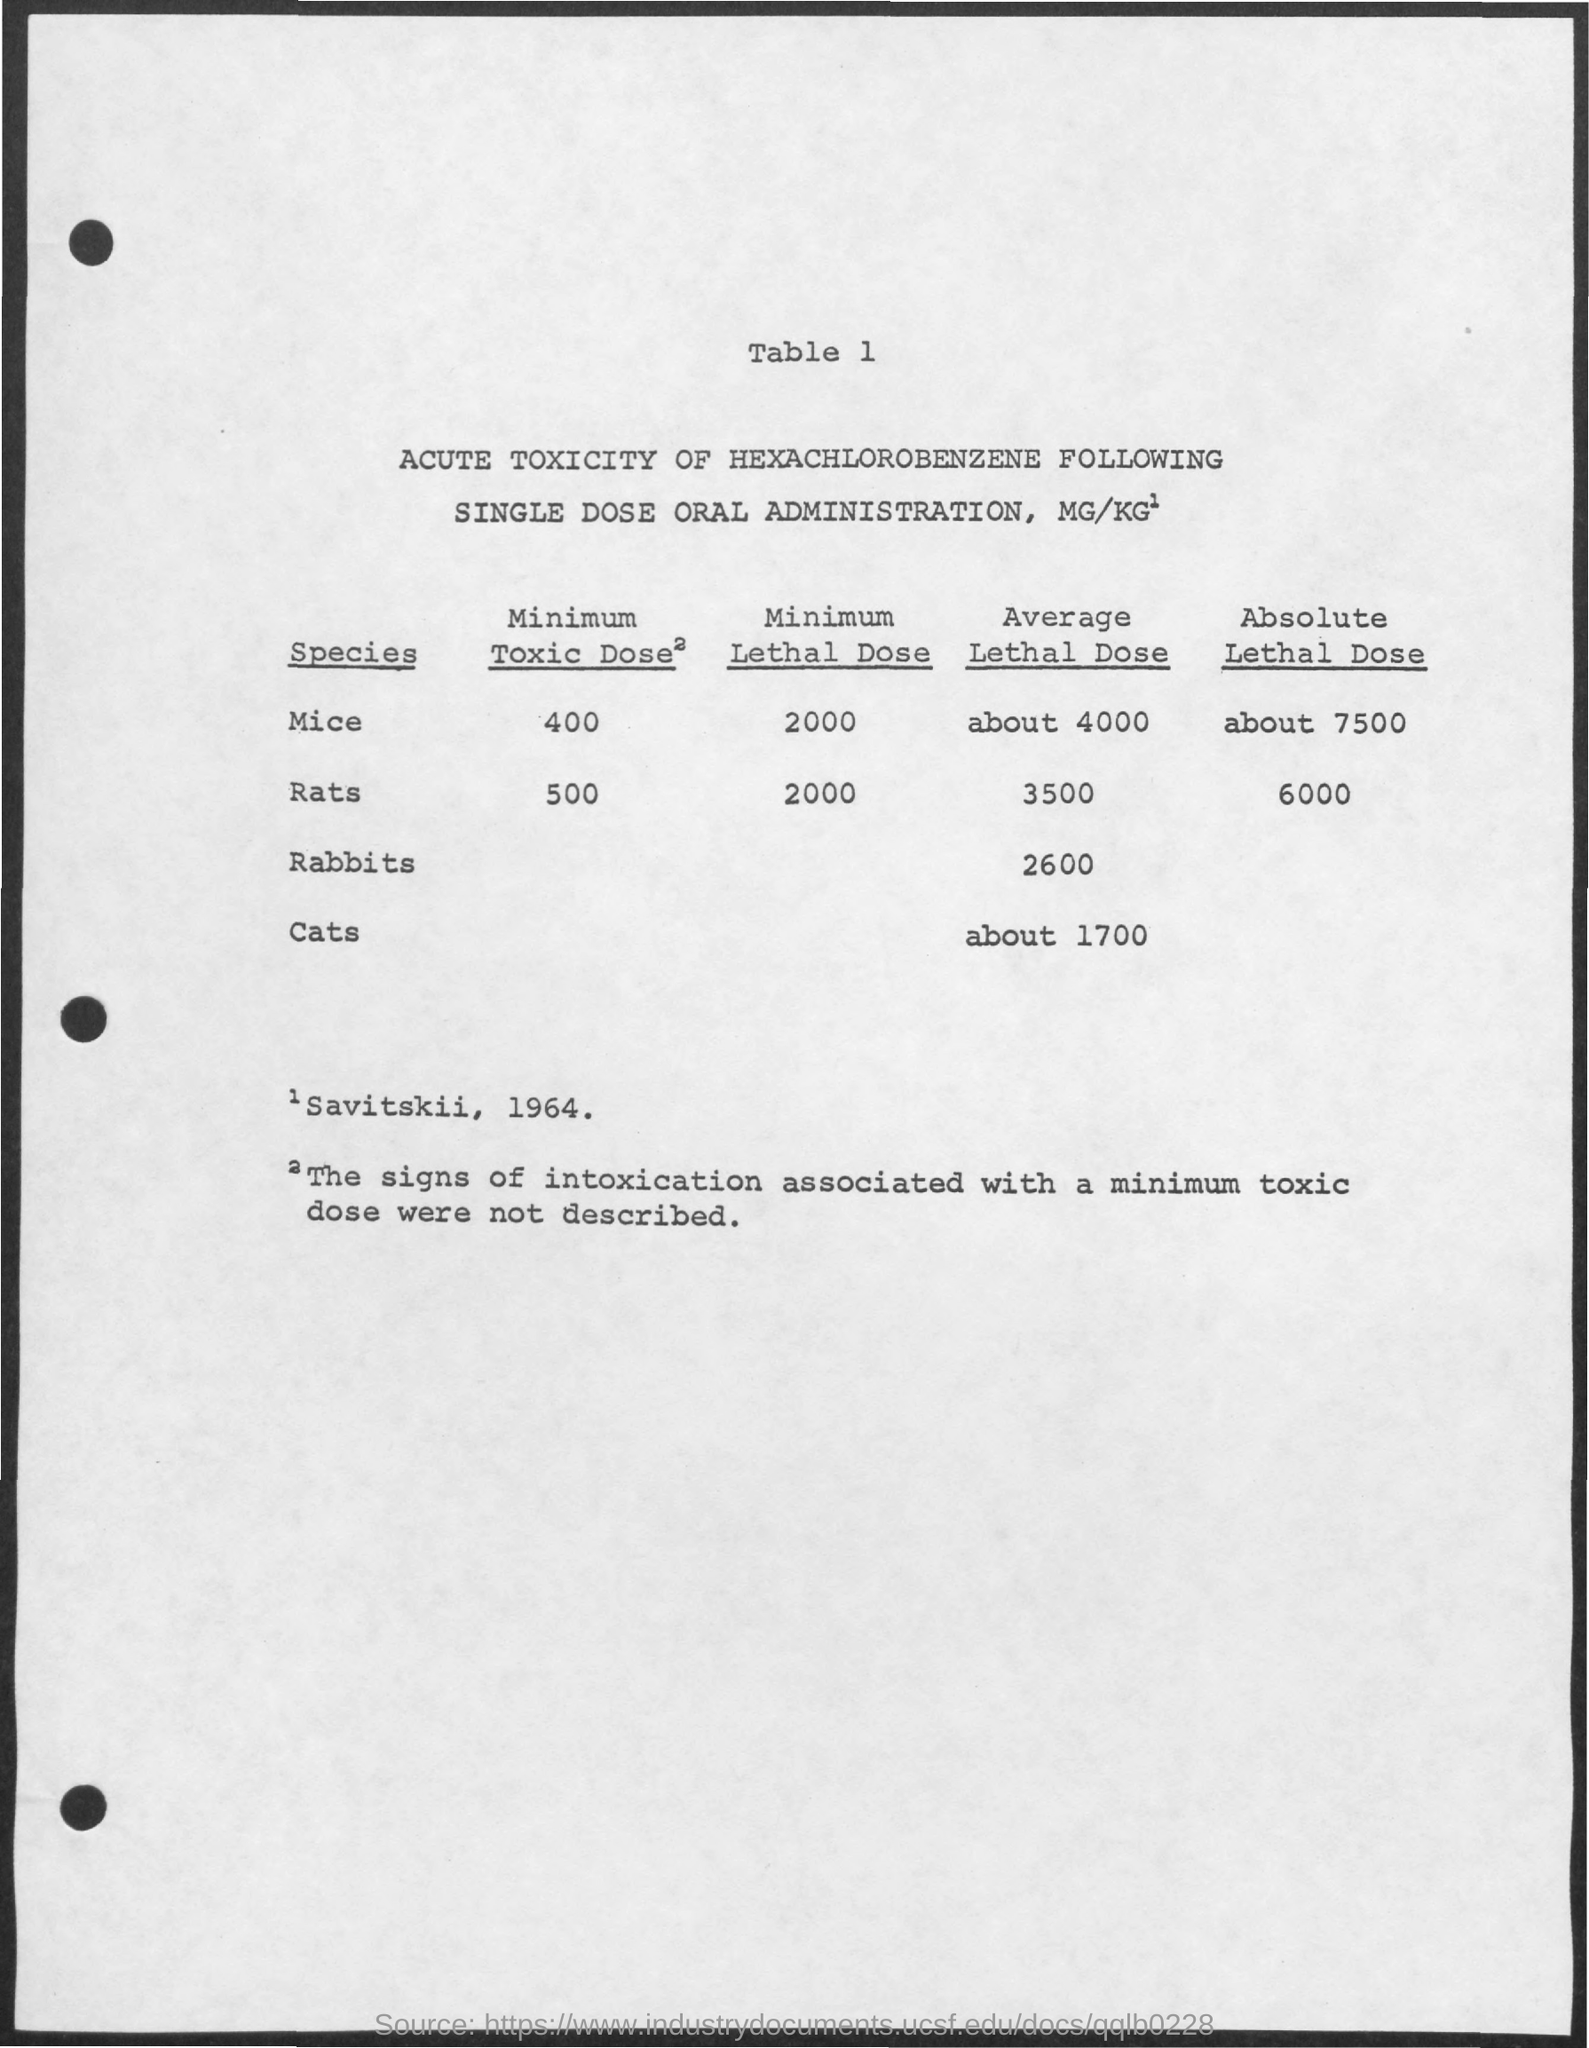What is the minimum lethal dose for Mice?
Make the answer very short. 2000. Which species has given the highest average lethal dose?
Ensure brevity in your answer.  Mice. What is the minimum toxic dose for mice?
Your answer should be compact. 400. What is the minimum lethal dose for rats?
Your response must be concise. 2000. Which species has given the highest absolute lethal dose?
Give a very brief answer. Mice. What is the average lethal dose for cats as per the Table 1?
Offer a very short reply. About 1700. 